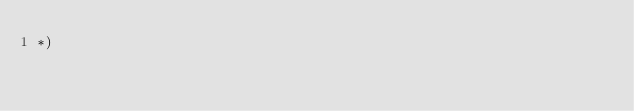Convert code to text. <code><loc_0><loc_0><loc_500><loc_500><_OCaml_>*)
</code> 